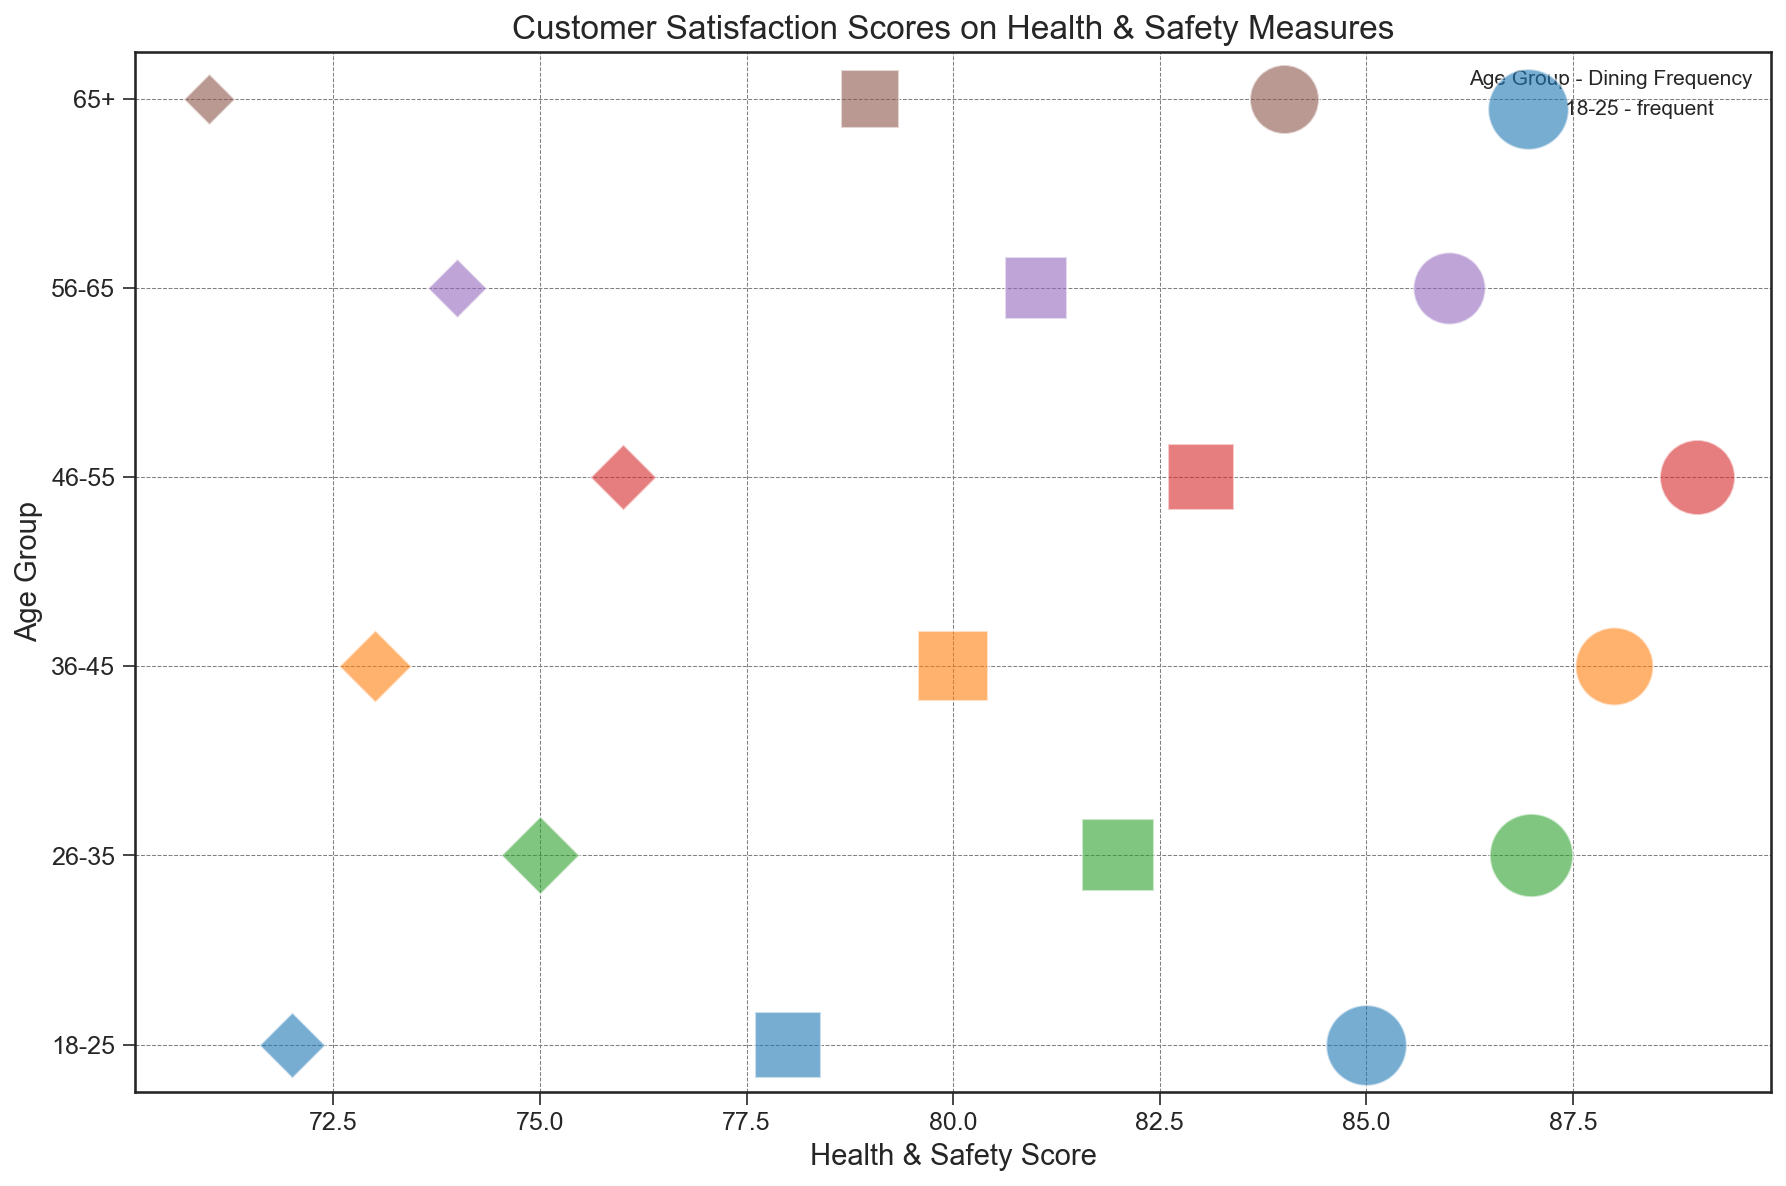Which age group and dining frequency combination has the highest health & safety score? The health & safety scores are plotted on the x-axis. The bubble with the highest value on the x-axis represents the highest score. The age group "46-55" with "frequent" dining frequency has the highest score of 89.
Answer: 46-55, frequent Which age group and dining frequency combination has the largest bubble size? Bubble size is proportional to customer counts, so the largest bubble represents the highest customer count. The "26-35" age group with "frequent" dining frequency has the largest bubble.
Answer: 26-35, frequent What is the average health & safety score for the "36-45" age group across all dining frequencies? The scores for "36-45" are 88 (frequent), 80 (occasional), and 73 (rare). The average is (88 + 80 + 73) / 3 = 241 / 3 = 80.33.
Answer: 80.33 Which age group shows more satisfaction with "occasional" dining frequency: "18-25" or "46-55"? Compare the health & safety scores of these age groups with "occasional" frequency. "18-25" has a score of 78 and "46-55" has 83, so "46-55" shows more satisfaction.
Answer: 46-55 For the "56-65" age group, what is the difference in health & safety scores between "frequent" and "occasional" dining frequencies? Compare the health & safety scores for "frequent" (86) and "occasional" (81) frequencies; the difference is 86 - 81 = 5.
Answer: 5 Which dining frequency generally shows the highest health & safety scores across all age groups? Examine the scores associated with each dining frequency; "frequent" dining frequency generally shows the highest scores across age groups.
Answer: frequent For the "65+" age group, which dining frequency has the smallest customer count? Check the bubble size for "65+"; the "rare" frequency has the smallest bubble, indicating the smallest customer count.
Answer: rare What is the combined customer count for the "46-55" age group across all dining frequencies? Sum the customer counts for "46-55" across "frequent" (130), "occasional" (100), and "rare" (50); total is 130 + 100 + 50 = 280.
Answer: 280 Between the "18-25" and "26-35" age groups, which has a higher health & safety score for "rare" dining frequency? Compare the scores for "rare" frequency in these age groups; "18-25" has 72 and "26-35" has 75, so "26-35" has a higher score.
Answer: 26-35 What is the total number of customers surveyed for the "36-45" age group? Sum the customer counts for "36-45": 140 (frequent), 110 (occasional), and 60 (rare); total is 140 + 110 + 60 = 310.
Answer: 310 